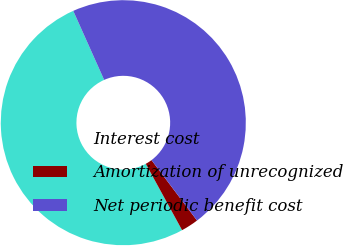Convert chart. <chart><loc_0><loc_0><loc_500><loc_500><pie_chart><fcel>Interest cost<fcel>Amortization of unrecognized<fcel>Net periodic benefit cost<nl><fcel>51.27%<fcel>2.31%<fcel>46.42%<nl></chart> 